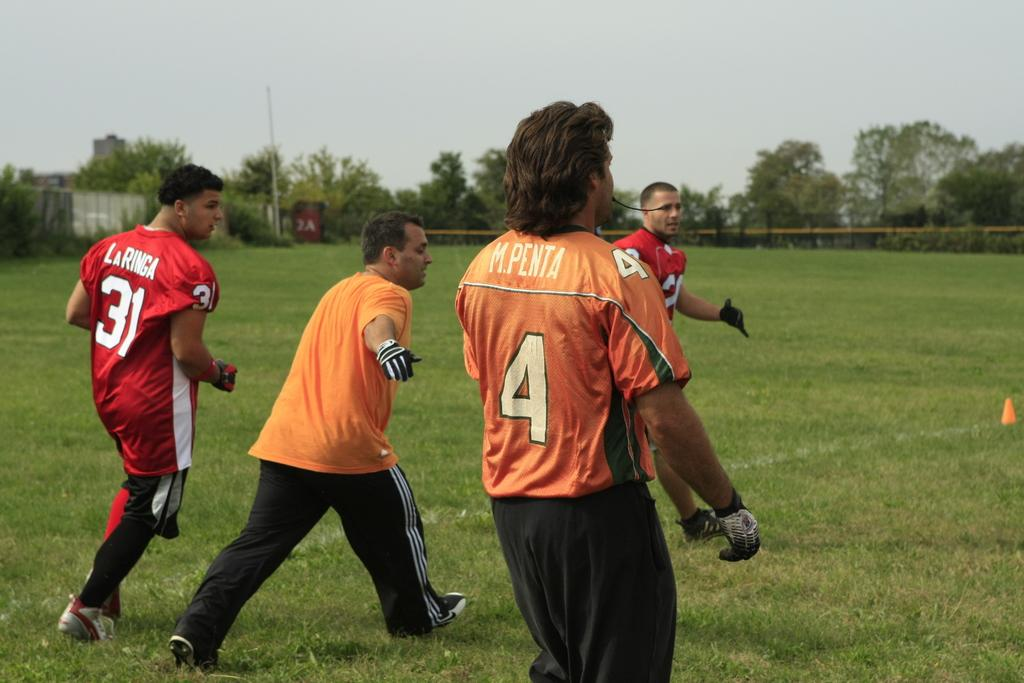What are the men in the image wearing? The men are wearing orange shirts and black track pants. What activity are the men engaged in? The men are playing. Where are the men standing in the image? The men are standing in the ground. What can be seen in the background of the image? There is a fencing railing and trees in the background. What type of work are the men doing in the image? The provided facts do not mention any work-related activity; the men are playing. Are there any slaves present in the image? There is no mention of slaves in the image; the men are wearing orange shirts and black track pants and are playing. 